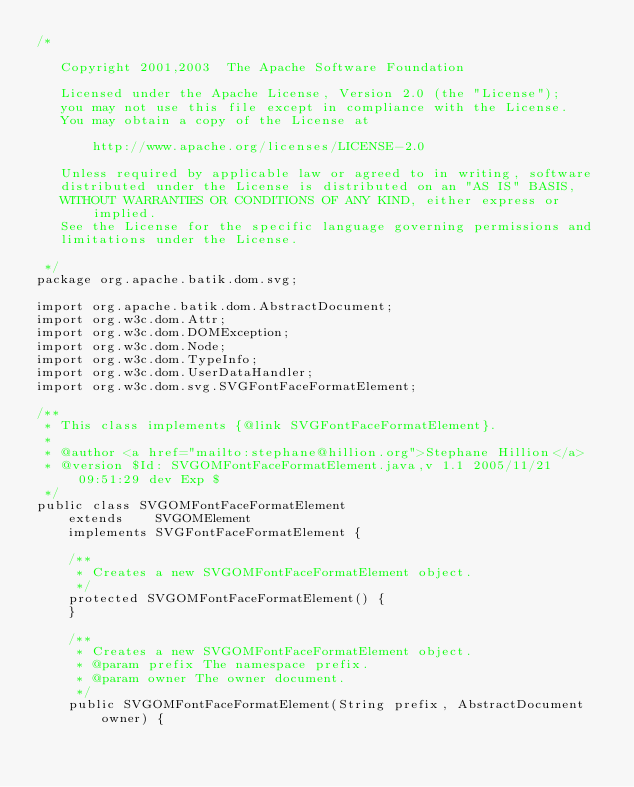Convert code to text. <code><loc_0><loc_0><loc_500><loc_500><_Java_>/*

   Copyright 2001,2003  The Apache Software Foundation 

   Licensed under the Apache License, Version 2.0 (the "License");
   you may not use this file except in compliance with the License.
   You may obtain a copy of the License at

       http://www.apache.org/licenses/LICENSE-2.0

   Unless required by applicable law or agreed to in writing, software
   distributed under the License is distributed on an "AS IS" BASIS,
   WITHOUT WARRANTIES OR CONDITIONS OF ANY KIND, either express or implied.
   See the License for the specific language governing permissions and
   limitations under the License.

 */
package org.apache.batik.dom.svg;

import org.apache.batik.dom.AbstractDocument;
import org.w3c.dom.Attr;
import org.w3c.dom.DOMException;
import org.w3c.dom.Node;
import org.w3c.dom.TypeInfo;
import org.w3c.dom.UserDataHandler;
import org.w3c.dom.svg.SVGFontFaceFormatElement;

/**
 * This class implements {@link SVGFontFaceFormatElement}.
 *
 * @author <a href="mailto:stephane@hillion.org">Stephane Hillion</a>
 * @version $Id: SVGOMFontFaceFormatElement.java,v 1.1 2005/11/21 09:51:29 dev Exp $
 */
public class SVGOMFontFaceFormatElement
    extends    SVGOMElement
    implements SVGFontFaceFormatElement {

    /**
     * Creates a new SVGOMFontFaceFormatElement object.
     */
    protected SVGOMFontFaceFormatElement() {
    }

    /**
     * Creates a new SVGOMFontFaceFormatElement object.
     * @param prefix The namespace prefix.
     * @param owner The owner document.
     */
    public SVGOMFontFaceFormatElement(String prefix, AbstractDocument owner) {</code> 